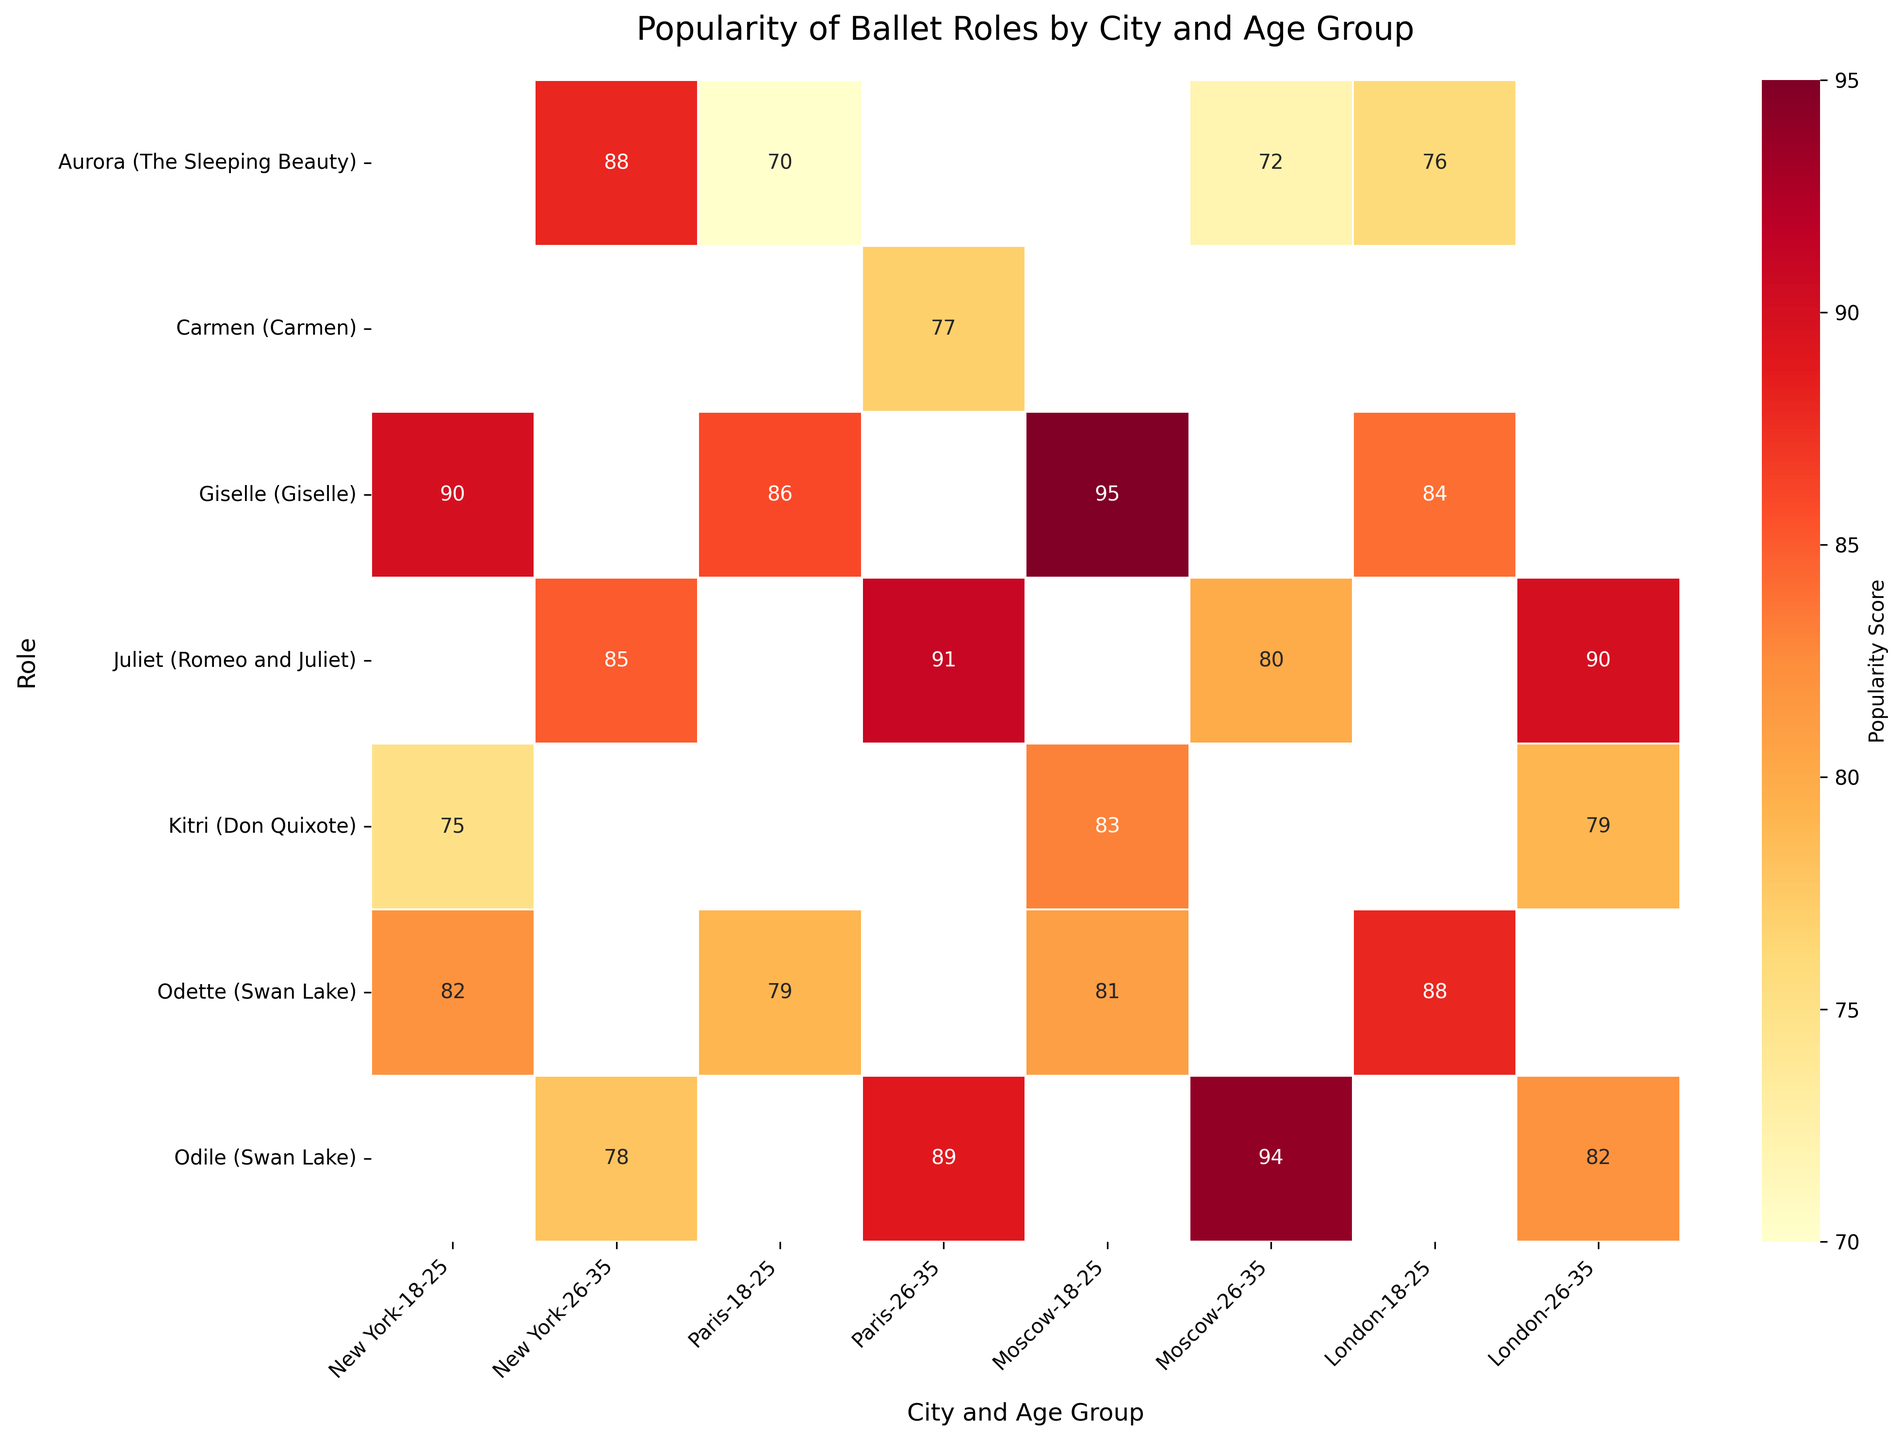What's the title of the figure? The title is generally placed at the top of the figure. By looking at the top part of the rendered heatmap, we can identify the title.
Answer: Popularity of Ballet Roles by City and Age Group Which role is most popular among 18-25 year-olds in Moscow? Look for the cell in the heatmap where the 'Role' is 'Giselle' and the 'City and Age Group' is 'Moscow, 18-25'. The cell value of 'Giselle' (95) is higher than other roles in the same group.
Answer: Giselle What city and age group has the highest popularity score for Juliet? Locate the 'Role' row for 'Juliet' and then compare the values across different 'City and Age Group' columns. The highest value is 91, which is in 'Paris, 26-35'.
Answer: Paris, 26-35 Is Odile more popular among 26-35 year-olds in Moscow or London? Compare the popularity scores of 'Odile' for 'Moscow, 26-35' and 'London, 26-35'. Moscow has 94 and London has 82.
Answer: Moscow How does the popularity of Odette compare between New York and London for the 18-25 age group? Look at the values of 'Odette' for 'New York, 18-25' and 'London, 18-25'. New York is 82 and London is 88.
Answer: London has a higher popularity score Which role’s popularity score sees the largest increase from the 18-25 age group to the 26-35 age group in Paris? Compare the scores for each role between the two age groups in Paris and find the difference. 'Odile' increases from not listed in 18-25 to 89 in 26-35.
Answer: Odile What's the average popularity score of the roles listed for London? Add the scores of all roles listed for London, then divide by the number of roles. (88 + 76 + 84 + 90 + 82 + 79) / 6 = 499 / 6 ≈ 83.2
Answer: 83.2 Which city has the most consistently high scores across all roles and age groups? Observe the cells in the heatmap across 'City and Age Group'. Moscow tends to have high scores consistently for both age groups.
Answer: Moscow What is the least popular role in New York for the 18-25 age group? Look at the popularity scores for 'New York, 18-25' across all roles. The lowest score is for 'Kitri' with 75.
Answer: Kitri 